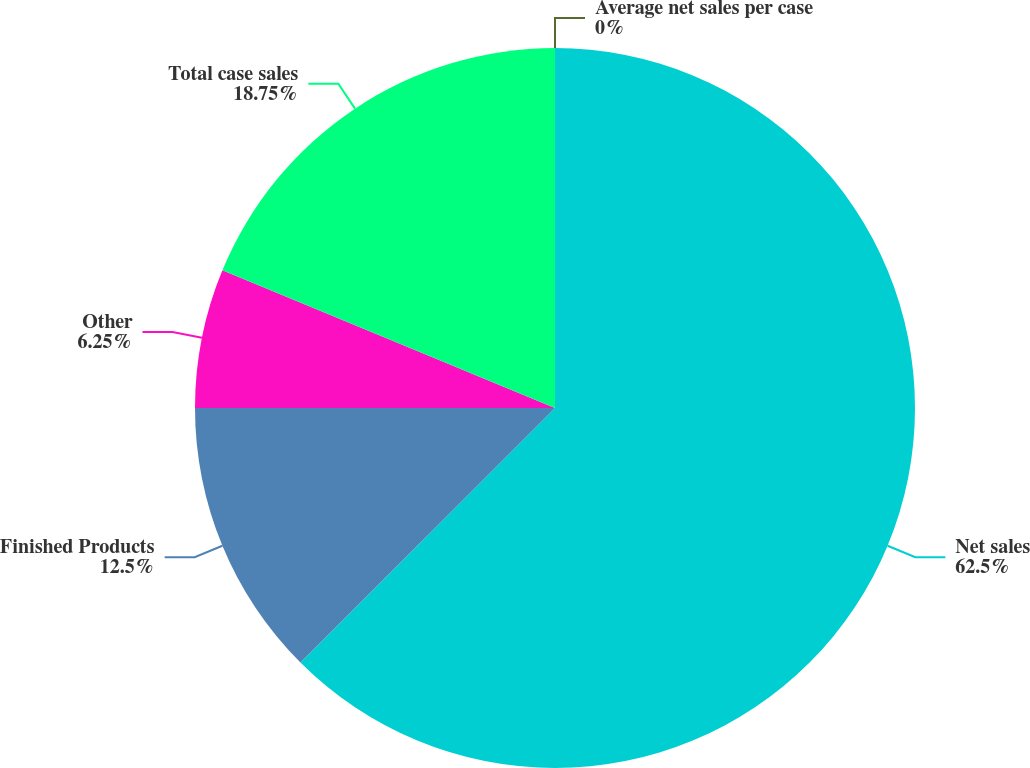Convert chart to OTSL. <chart><loc_0><loc_0><loc_500><loc_500><pie_chart><fcel>Net sales<fcel>Finished Products<fcel>Other<fcel>Total case sales<fcel>Average net sales per case<nl><fcel>62.5%<fcel>12.5%<fcel>6.25%<fcel>18.75%<fcel>0.0%<nl></chart> 